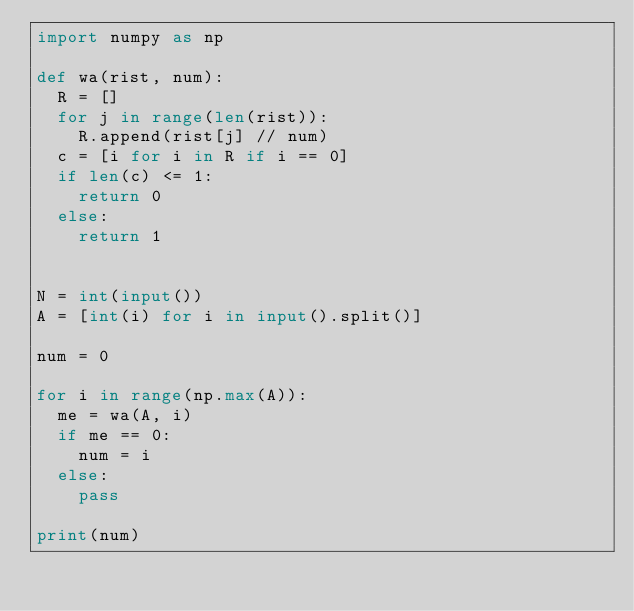Convert code to text. <code><loc_0><loc_0><loc_500><loc_500><_Python_>import numpy as np

def wa(rist, num):
  R = []
  for j in range(len(rist)):
    R.append(rist[j] // num)
  c = [i for i in R if i == 0]
  if len(c) <= 1:
    return 0
  else:
    return 1
    

N = int(input())
A = [int(i) for i in input().split()]

num = 0

for i in range(np.max(A)):
  me = wa(A, i)
  if me == 0:
    num = i
  else:
    pass
  
print(num)
</code> 